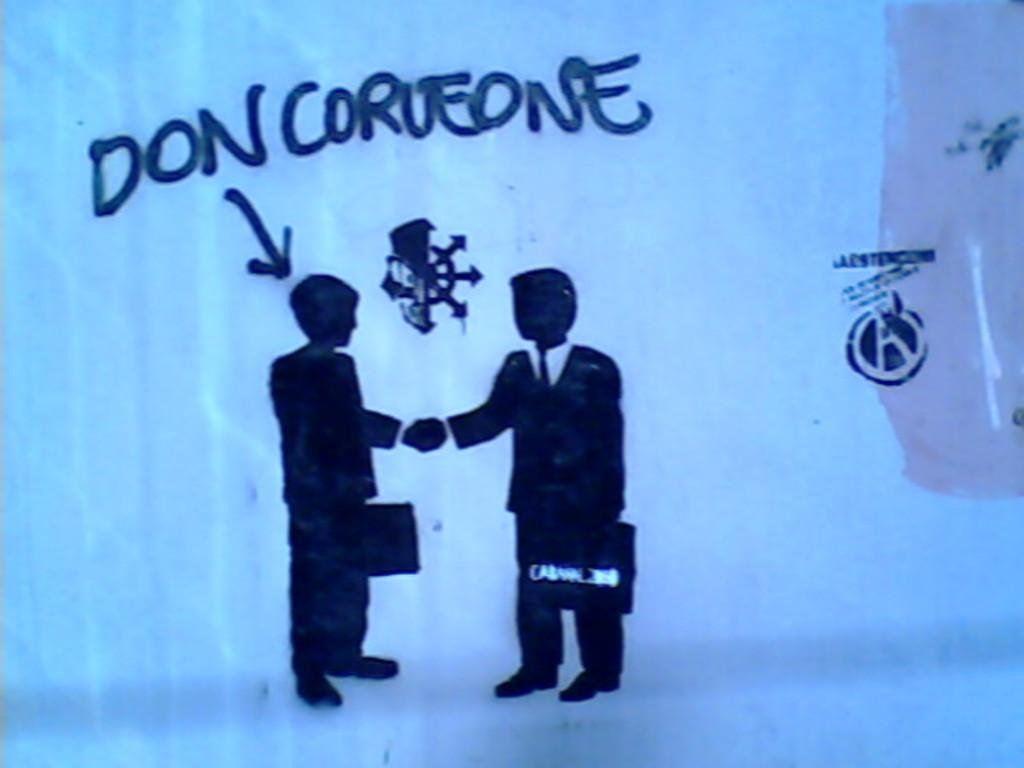<image>
Offer a succinct explanation of the picture presented. A painting of two men with the name Don Corleone pointed at one of them. 